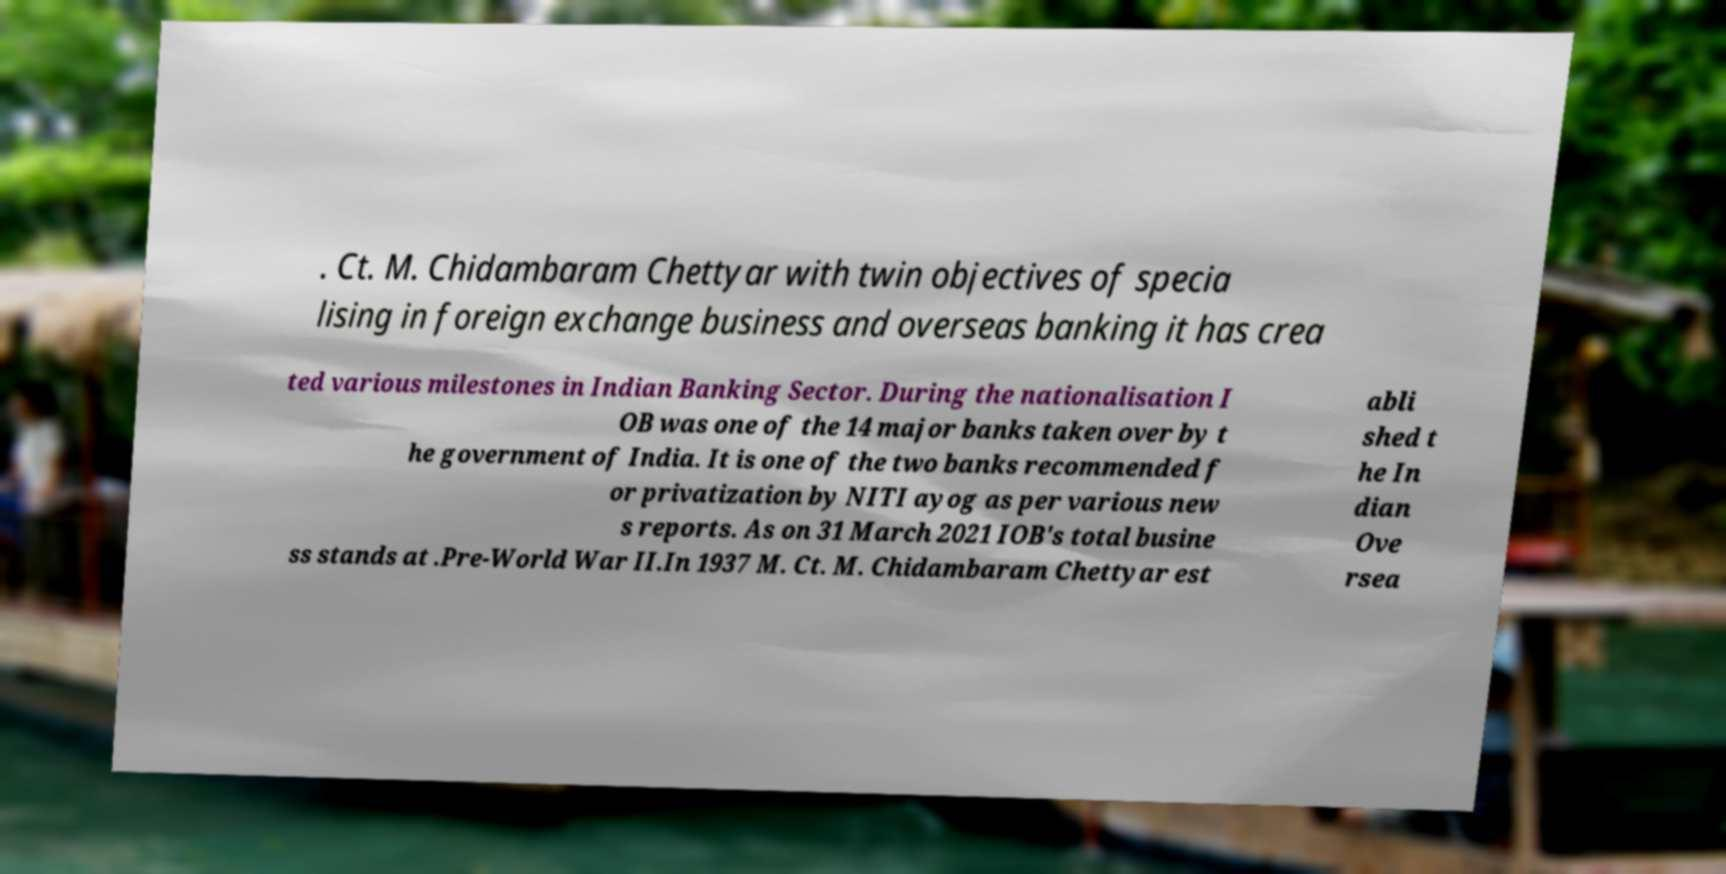Could you assist in decoding the text presented in this image and type it out clearly? . Ct. M. Chidambaram Chettyar with twin objectives of specia lising in foreign exchange business and overseas banking it has crea ted various milestones in Indian Banking Sector. During the nationalisation I OB was one of the 14 major banks taken over by t he government of India. It is one of the two banks recommended f or privatization by NITI ayog as per various new s reports. As on 31 March 2021 IOB's total busine ss stands at .Pre-World War II.In 1937 M. Ct. M. Chidambaram Chettyar est abli shed t he In dian Ove rsea 